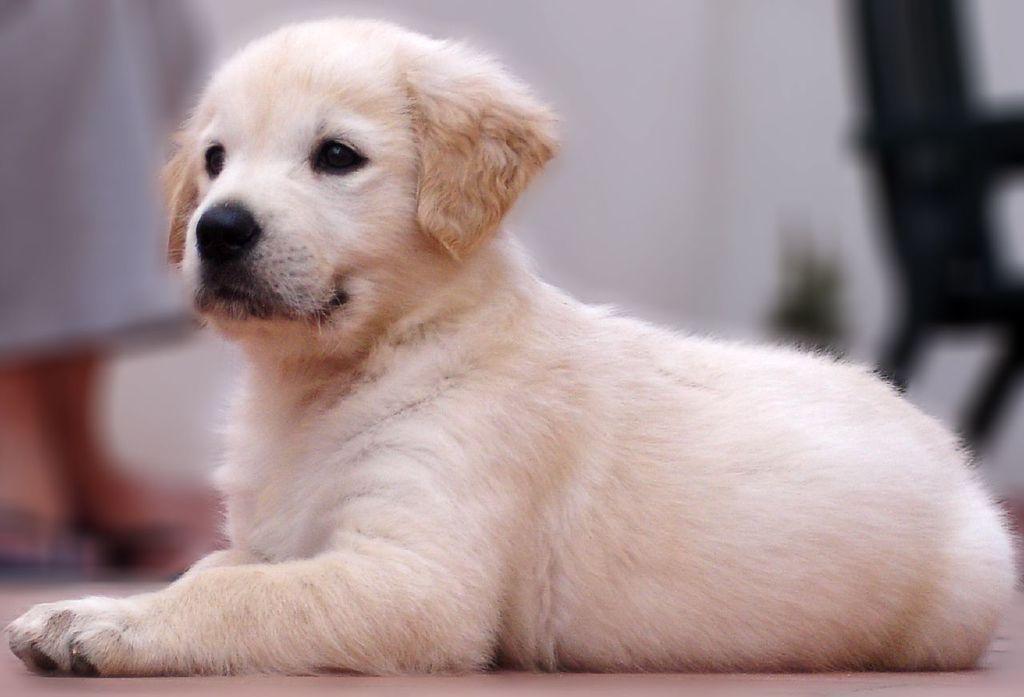Please provide a concise description of this image. In this image in the center there is one dog, and in the background there is one person who is standing and also there is one chair. 